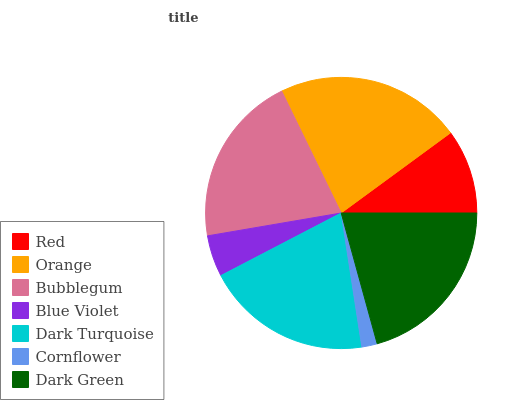Is Cornflower the minimum?
Answer yes or no. Yes. Is Orange the maximum?
Answer yes or no. Yes. Is Bubblegum the minimum?
Answer yes or no. No. Is Bubblegum the maximum?
Answer yes or no. No. Is Orange greater than Bubblegum?
Answer yes or no. Yes. Is Bubblegum less than Orange?
Answer yes or no. Yes. Is Bubblegum greater than Orange?
Answer yes or no. No. Is Orange less than Bubblegum?
Answer yes or no. No. Is Dark Turquoise the high median?
Answer yes or no. Yes. Is Dark Turquoise the low median?
Answer yes or no. Yes. Is Cornflower the high median?
Answer yes or no. No. Is Cornflower the low median?
Answer yes or no. No. 